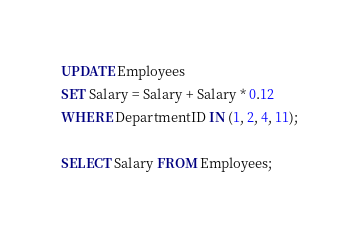<code> <loc_0><loc_0><loc_500><loc_500><_SQL_>UPDATE Employees
SET Salary = Salary + Salary * 0.12
WHERE DepartmentID IN (1, 2, 4, 11);

SELECT Salary FROM Employees;</code> 